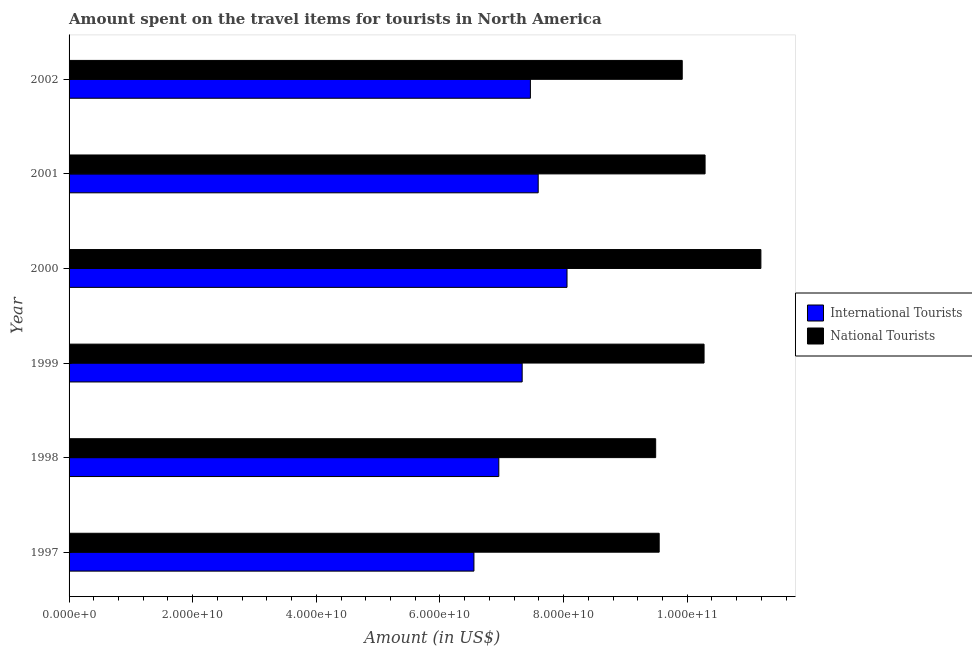How many groups of bars are there?
Offer a terse response. 6. How many bars are there on the 3rd tick from the top?
Provide a succinct answer. 2. How many bars are there on the 1st tick from the bottom?
Give a very brief answer. 2. What is the label of the 3rd group of bars from the top?
Your answer should be compact. 2000. In how many cases, is the number of bars for a given year not equal to the number of legend labels?
Your answer should be compact. 0. What is the amount spent on travel items of international tourists in 1999?
Offer a very short reply. 7.33e+1. Across all years, what is the maximum amount spent on travel items of international tourists?
Make the answer very short. 8.06e+1. Across all years, what is the minimum amount spent on travel items of international tourists?
Offer a terse response. 6.55e+1. In which year was the amount spent on travel items of national tourists minimum?
Make the answer very short. 1998. What is the total amount spent on travel items of international tourists in the graph?
Your response must be concise. 4.39e+11. What is the difference between the amount spent on travel items of national tourists in 2000 and that in 2002?
Give a very brief answer. 1.27e+1. What is the difference between the amount spent on travel items of national tourists in 2002 and the amount spent on travel items of international tourists in 1997?
Keep it short and to the point. 3.37e+1. What is the average amount spent on travel items of national tourists per year?
Your answer should be compact. 1.01e+11. In the year 2001, what is the difference between the amount spent on travel items of national tourists and amount spent on travel items of international tourists?
Give a very brief answer. 2.70e+1. What is the ratio of the amount spent on travel items of international tourists in 1997 to that in 2002?
Your response must be concise. 0.88. Is the difference between the amount spent on travel items of international tourists in 1997 and 1999 greater than the difference between the amount spent on travel items of national tourists in 1997 and 1999?
Give a very brief answer. No. What is the difference between the highest and the second highest amount spent on travel items of international tourists?
Offer a terse response. 4.66e+09. What is the difference between the highest and the lowest amount spent on travel items of national tourists?
Keep it short and to the point. 1.70e+1. Is the sum of the amount spent on travel items of national tourists in 1997 and 2001 greater than the maximum amount spent on travel items of international tourists across all years?
Offer a very short reply. Yes. What does the 1st bar from the top in 2001 represents?
Provide a short and direct response. National Tourists. What does the 2nd bar from the bottom in 1998 represents?
Provide a succinct answer. National Tourists. What is the difference between two consecutive major ticks on the X-axis?
Keep it short and to the point. 2.00e+1. Are the values on the major ticks of X-axis written in scientific E-notation?
Make the answer very short. Yes. Where does the legend appear in the graph?
Keep it short and to the point. Center right. How are the legend labels stacked?
Offer a terse response. Vertical. What is the title of the graph?
Provide a short and direct response. Amount spent on the travel items for tourists in North America. Does "Sanitation services" appear as one of the legend labels in the graph?
Give a very brief answer. No. What is the label or title of the Y-axis?
Make the answer very short. Year. What is the Amount (in US$) in International Tourists in 1997?
Offer a terse response. 6.55e+1. What is the Amount (in US$) in National Tourists in 1997?
Your answer should be compact. 9.55e+1. What is the Amount (in US$) of International Tourists in 1998?
Your answer should be compact. 6.95e+1. What is the Amount (in US$) in National Tourists in 1998?
Provide a succinct answer. 9.49e+1. What is the Amount (in US$) in International Tourists in 1999?
Your response must be concise. 7.33e+1. What is the Amount (in US$) of National Tourists in 1999?
Ensure brevity in your answer.  1.03e+11. What is the Amount (in US$) of International Tourists in 2000?
Provide a short and direct response. 8.06e+1. What is the Amount (in US$) of National Tourists in 2000?
Make the answer very short. 1.12e+11. What is the Amount (in US$) of International Tourists in 2001?
Offer a terse response. 7.59e+1. What is the Amount (in US$) of National Tourists in 2001?
Ensure brevity in your answer.  1.03e+11. What is the Amount (in US$) in International Tourists in 2002?
Offer a terse response. 7.46e+1. What is the Amount (in US$) of National Tourists in 2002?
Offer a very short reply. 9.92e+1. Across all years, what is the maximum Amount (in US$) of International Tourists?
Make the answer very short. 8.06e+1. Across all years, what is the maximum Amount (in US$) of National Tourists?
Offer a very short reply. 1.12e+11. Across all years, what is the minimum Amount (in US$) in International Tourists?
Make the answer very short. 6.55e+1. Across all years, what is the minimum Amount (in US$) in National Tourists?
Ensure brevity in your answer.  9.49e+1. What is the total Amount (in US$) in International Tourists in the graph?
Give a very brief answer. 4.39e+11. What is the total Amount (in US$) of National Tourists in the graph?
Your answer should be compact. 6.07e+11. What is the difference between the Amount (in US$) of International Tourists in 1997 and that in 1998?
Give a very brief answer. -4.03e+09. What is the difference between the Amount (in US$) of National Tourists in 1997 and that in 1998?
Your answer should be very brief. 5.70e+08. What is the difference between the Amount (in US$) in International Tourists in 1997 and that in 1999?
Make the answer very short. -7.80e+09. What is the difference between the Amount (in US$) in National Tourists in 1997 and that in 1999?
Offer a terse response. -7.26e+09. What is the difference between the Amount (in US$) in International Tourists in 1997 and that in 2000?
Offer a very short reply. -1.51e+1. What is the difference between the Amount (in US$) in National Tourists in 1997 and that in 2000?
Ensure brevity in your answer.  -1.65e+1. What is the difference between the Amount (in US$) in International Tourists in 1997 and that in 2001?
Make the answer very short. -1.04e+1. What is the difference between the Amount (in US$) in National Tourists in 1997 and that in 2001?
Make the answer very short. -7.42e+09. What is the difference between the Amount (in US$) in International Tourists in 1997 and that in 2002?
Your response must be concise. -9.13e+09. What is the difference between the Amount (in US$) in National Tourists in 1997 and that in 2002?
Provide a short and direct response. -3.73e+09. What is the difference between the Amount (in US$) in International Tourists in 1998 and that in 1999?
Provide a short and direct response. -3.78e+09. What is the difference between the Amount (in US$) of National Tourists in 1998 and that in 1999?
Offer a very short reply. -7.83e+09. What is the difference between the Amount (in US$) of International Tourists in 1998 and that in 2000?
Keep it short and to the point. -1.10e+1. What is the difference between the Amount (in US$) of National Tourists in 1998 and that in 2000?
Make the answer very short. -1.70e+1. What is the difference between the Amount (in US$) of International Tourists in 1998 and that in 2001?
Provide a succinct answer. -6.37e+09. What is the difference between the Amount (in US$) in National Tourists in 1998 and that in 2001?
Provide a succinct answer. -7.99e+09. What is the difference between the Amount (in US$) of International Tourists in 1998 and that in 2002?
Give a very brief answer. -5.11e+09. What is the difference between the Amount (in US$) of National Tourists in 1998 and that in 2002?
Offer a terse response. -4.30e+09. What is the difference between the Amount (in US$) in International Tourists in 1999 and that in 2000?
Provide a short and direct response. -7.26e+09. What is the difference between the Amount (in US$) in National Tourists in 1999 and that in 2000?
Provide a succinct answer. -9.19e+09. What is the difference between the Amount (in US$) of International Tourists in 1999 and that in 2001?
Your answer should be very brief. -2.59e+09. What is the difference between the Amount (in US$) in National Tourists in 1999 and that in 2001?
Offer a terse response. -1.64e+08. What is the difference between the Amount (in US$) of International Tourists in 1999 and that in 2002?
Provide a short and direct response. -1.33e+09. What is the difference between the Amount (in US$) of National Tourists in 1999 and that in 2002?
Give a very brief answer. 3.53e+09. What is the difference between the Amount (in US$) of International Tourists in 2000 and that in 2001?
Your answer should be compact. 4.66e+09. What is the difference between the Amount (in US$) of National Tourists in 2000 and that in 2001?
Offer a terse response. 9.03e+09. What is the difference between the Amount (in US$) in International Tourists in 2000 and that in 2002?
Make the answer very short. 5.92e+09. What is the difference between the Amount (in US$) of National Tourists in 2000 and that in 2002?
Offer a very short reply. 1.27e+1. What is the difference between the Amount (in US$) in International Tourists in 2001 and that in 2002?
Make the answer very short. 1.26e+09. What is the difference between the Amount (in US$) in National Tourists in 2001 and that in 2002?
Keep it short and to the point. 3.70e+09. What is the difference between the Amount (in US$) of International Tourists in 1997 and the Amount (in US$) of National Tourists in 1998?
Offer a terse response. -2.94e+1. What is the difference between the Amount (in US$) of International Tourists in 1997 and the Amount (in US$) of National Tourists in 1999?
Your response must be concise. -3.72e+1. What is the difference between the Amount (in US$) of International Tourists in 1997 and the Amount (in US$) of National Tourists in 2000?
Provide a succinct answer. -4.64e+1. What is the difference between the Amount (in US$) of International Tourists in 1997 and the Amount (in US$) of National Tourists in 2001?
Offer a terse response. -3.74e+1. What is the difference between the Amount (in US$) in International Tourists in 1997 and the Amount (in US$) in National Tourists in 2002?
Give a very brief answer. -3.37e+1. What is the difference between the Amount (in US$) of International Tourists in 1998 and the Amount (in US$) of National Tourists in 1999?
Ensure brevity in your answer.  -3.32e+1. What is the difference between the Amount (in US$) of International Tourists in 1998 and the Amount (in US$) of National Tourists in 2000?
Ensure brevity in your answer.  -4.24e+1. What is the difference between the Amount (in US$) of International Tourists in 1998 and the Amount (in US$) of National Tourists in 2001?
Offer a very short reply. -3.34e+1. What is the difference between the Amount (in US$) in International Tourists in 1998 and the Amount (in US$) in National Tourists in 2002?
Provide a short and direct response. -2.97e+1. What is the difference between the Amount (in US$) of International Tourists in 1999 and the Amount (in US$) of National Tourists in 2000?
Give a very brief answer. -3.86e+1. What is the difference between the Amount (in US$) of International Tourists in 1999 and the Amount (in US$) of National Tourists in 2001?
Make the answer very short. -2.96e+1. What is the difference between the Amount (in US$) in International Tourists in 1999 and the Amount (in US$) in National Tourists in 2002?
Keep it short and to the point. -2.59e+1. What is the difference between the Amount (in US$) of International Tourists in 2000 and the Amount (in US$) of National Tourists in 2001?
Ensure brevity in your answer.  -2.23e+1. What is the difference between the Amount (in US$) in International Tourists in 2000 and the Amount (in US$) in National Tourists in 2002?
Your response must be concise. -1.86e+1. What is the difference between the Amount (in US$) in International Tourists in 2001 and the Amount (in US$) in National Tourists in 2002?
Make the answer very short. -2.33e+1. What is the average Amount (in US$) of International Tourists per year?
Provide a succinct answer. 7.32e+1. What is the average Amount (in US$) in National Tourists per year?
Keep it short and to the point. 1.01e+11. In the year 1997, what is the difference between the Amount (in US$) of International Tourists and Amount (in US$) of National Tourists?
Your answer should be compact. -3.00e+1. In the year 1998, what is the difference between the Amount (in US$) in International Tourists and Amount (in US$) in National Tourists?
Give a very brief answer. -2.54e+1. In the year 1999, what is the difference between the Amount (in US$) in International Tourists and Amount (in US$) in National Tourists?
Keep it short and to the point. -2.94e+1. In the year 2000, what is the difference between the Amount (in US$) of International Tourists and Amount (in US$) of National Tourists?
Provide a short and direct response. -3.14e+1. In the year 2001, what is the difference between the Amount (in US$) in International Tourists and Amount (in US$) in National Tourists?
Offer a very short reply. -2.70e+1. In the year 2002, what is the difference between the Amount (in US$) of International Tourists and Amount (in US$) of National Tourists?
Offer a very short reply. -2.46e+1. What is the ratio of the Amount (in US$) of International Tourists in 1997 to that in 1998?
Give a very brief answer. 0.94. What is the ratio of the Amount (in US$) in National Tourists in 1997 to that in 1998?
Provide a succinct answer. 1.01. What is the ratio of the Amount (in US$) of International Tourists in 1997 to that in 1999?
Your answer should be compact. 0.89. What is the ratio of the Amount (in US$) in National Tourists in 1997 to that in 1999?
Offer a very short reply. 0.93. What is the ratio of the Amount (in US$) of International Tourists in 1997 to that in 2000?
Make the answer very short. 0.81. What is the ratio of the Amount (in US$) in National Tourists in 1997 to that in 2000?
Provide a succinct answer. 0.85. What is the ratio of the Amount (in US$) in International Tourists in 1997 to that in 2001?
Give a very brief answer. 0.86. What is the ratio of the Amount (in US$) in National Tourists in 1997 to that in 2001?
Give a very brief answer. 0.93. What is the ratio of the Amount (in US$) in International Tourists in 1997 to that in 2002?
Your answer should be very brief. 0.88. What is the ratio of the Amount (in US$) of National Tourists in 1997 to that in 2002?
Make the answer very short. 0.96. What is the ratio of the Amount (in US$) in International Tourists in 1998 to that in 1999?
Make the answer very short. 0.95. What is the ratio of the Amount (in US$) in National Tourists in 1998 to that in 1999?
Offer a terse response. 0.92. What is the ratio of the Amount (in US$) in International Tourists in 1998 to that in 2000?
Provide a short and direct response. 0.86. What is the ratio of the Amount (in US$) of National Tourists in 1998 to that in 2000?
Your answer should be very brief. 0.85. What is the ratio of the Amount (in US$) of International Tourists in 1998 to that in 2001?
Provide a succinct answer. 0.92. What is the ratio of the Amount (in US$) in National Tourists in 1998 to that in 2001?
Your answer should be compact. 0.92. What is the ratio of the Amount (in US$) in International Tourists in 1998 to that in 2002?
Provide a short and direct response. 0.93. What is the ratio of the Amount (in US$) of National Tourists in 1998 to that in 2002?
Provide a short and direct response. 0.96. What is the ratio of the Amount (in US$) of International Tourists in 1999 to that in 2000?
Your answer should be compact. 0.91. What is the ratio of the Amount (in US$) in National Tourists in 1999 to that in 2000?
Offer a very short reply. 0.92. What is the ratio of the Amount (in US$) of International Tourists in 1999 to that in 2001?
Make the answer very short. 0.97. What is the ratio of the Amount (in US$) of National Tourists in 1999 to that in 2001?
Offer a terse response. 1. What is the ratio of the Amount (in US$) in International Tourists in 1999 to that in 2002?
Provide a short and direct response. 0.98. What is the ratio of the Amount (in US$) in National Tourists in 1999 to that in 2002?
Give a very brief answer. 1.04. What is the ratio of the Amount (in US$) in International Tourists in 2000 to that in 2001?
Offer a terse response. 1.06. What is the ratio of the Amount (in US$) of National Tourists in 2000 to that in 2001?
Give a very brief answer. 1.09. What is the ratio of the Amount (in US$) of International Tourists in 2000 to that in 2002?
Ensure brevity in your answer.  1.08. What is the ratio of the Amount (in US$) of National Tourists in 2000 to that in 2002?
Ensure brevity in your answer.  1.13. What is the ratio of the Amount (in US$) of International Tourists in 2001 to that in 2002?
Keep it short and to the point. 1.02. What is the ratio of the Amount (in US$) in National Tourists in 2001 to that in 2002?
Offer a very short reply. 1.04. What is the difference between the highest and the second highest Amount (in US$) in International Tourists?
Your answer should be very brief. 4.66e+09. What is the difference between the highest and the second highest Amount (in US$) in National Tourists?
Offer a terse response. 9.03e+09. What is the difference between the highest and the lowest Amount (in US$) in International Tourists?
Your answer should be compact. 1.51e+1. What is the difference between the highest and the lowest Amount (in US$) of National Tourists?
Give a very brief answer. 1.70e+1. 